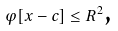<formula> <loc_0><loc_0><loc_500><loc_500>\varphi [ x - c ] \leq R ^ { 2 } \text {,}</formula> 